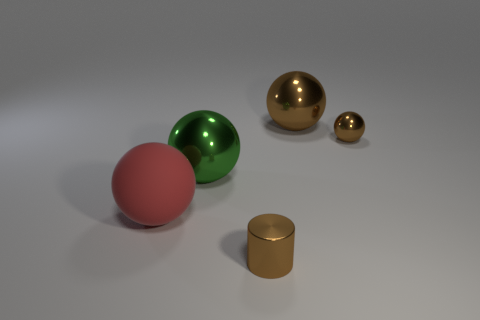Add 5 green metal spheres. How many objects exist? 10 Subtract all balls. How many objects are left? 1 Add 5 small cylinders. How many small cylinders are left? 6 Add 3 metal spheres. How many metal spheres exist? 6 Subtract 0 yellow blocks. How many objects are left? 5 Subtract all small brown cylinders. Subtract all brown shiny cylinders. How many objects are left? 3 